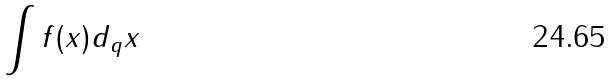Convert formula to latex. <formula><loc_0><loc_0><loc_500><loc_500>\int f ( x ) d _ { q } x</formula> 